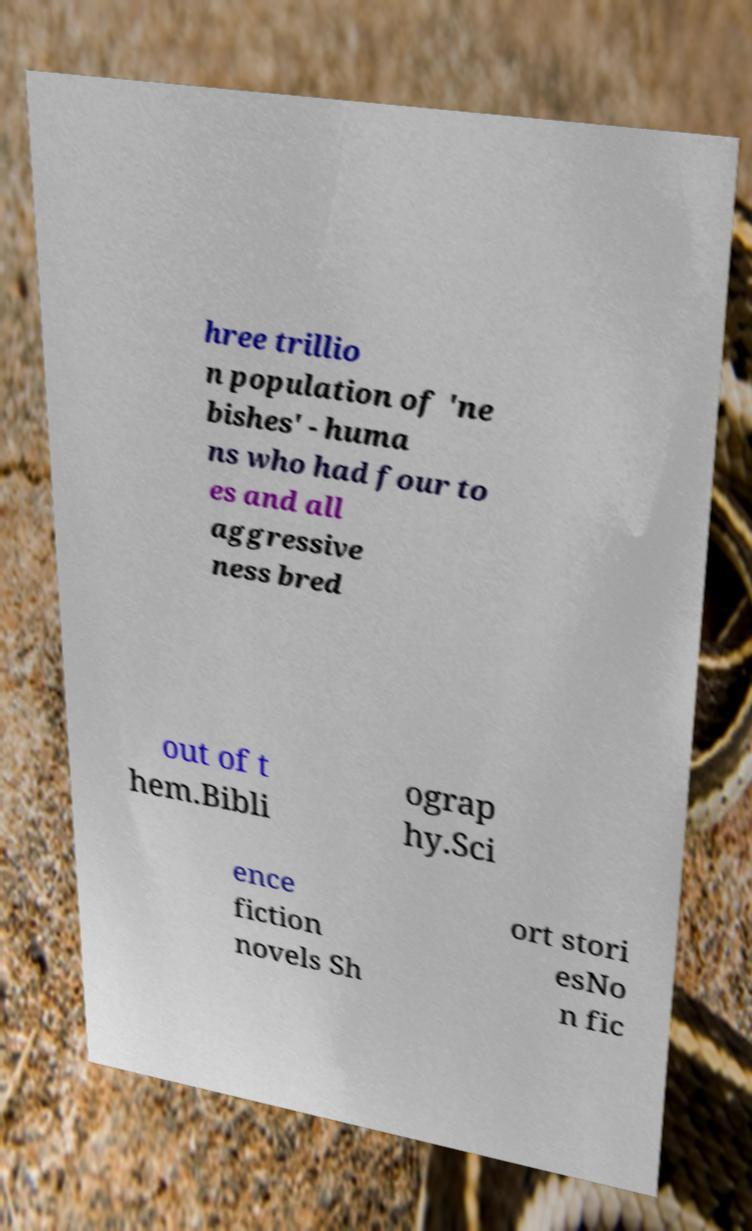Could you assist in decoding the text presented in this image and type it out clearly? hree trillio n population of 'ne bishes' - huma ns who had four to es and all aggressive ness bred out of t hem.Bibli ograp hy.Sci ence fiction novels Sh ort stori esNo n fic 